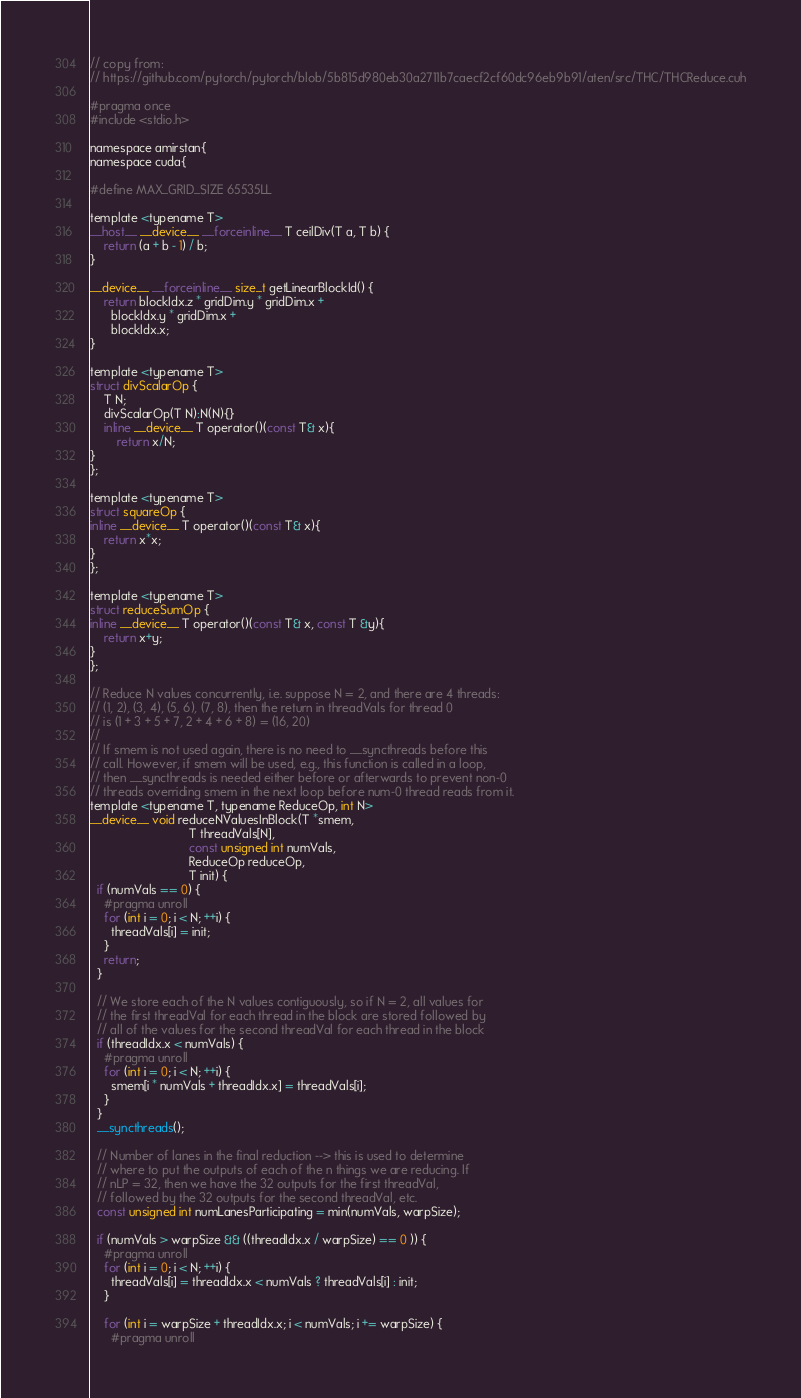Convert code to text. <code><loc_0><loc_0><loc_500><loc_500><_Cuda_>// copy from:
// https://github.com/pytorch/pytorch/blob/5b815d980eb30a2711b7caecf2cf60dc96eb9b91/aten/src/THC/THCReduce.cuh

#pragma once
#include <stdio.h>

namespace amirstan{
namespace cuda{

#define MAX_GRID_SIZE 65535LL

template <typename T>
__host__ __device__ __forceinline__ T ceilDiv(T a, T b) {
    return (a + b - 1) / b;
}

__device__ __forceinline__ size_t getLinearBlockId() {
    return blockIdx.z * gridDim.y * gridDim.x +
      blockIdx.y * gridDim.x +
      blockIdx.x;
}

template <typename T>
struct divScalarOp {
    T N;
    divScalarOp(T N):N(N){}
    inline __device__ T operator()(const T& x){
        return x/N;
}
};

template <typename T>
struct squareOp {
inline __device__ T operator()(const T& x){
    return x*x;
}
};

template <typename T>
struct reduceSumOp {
inline __device__ T operator()(const T& x, const T &y){
    return x+y;
}
};

// Reduce N values concurrently, i.e. suppose N = 2, and there are 4 threads:
// (1, 2), (3, 4), (5, 6), (7, 8), then the return in threadVals for thread 0
// is (1 + 3 + 5 + 7, 2 + 4 + 6 + 8) = (16, 20)
//
// If smem is not used again, there is no need to __syncthreads before this
// call. However, if smem will be used, e.g., this function is called in a loop,
// then __syncthreads is needed either before or afterwards to prevent non-0
// threads overriding smem in the next loop before num-0 thread reads from it.
template <typename T, typename ReduceOp, int N>
__device__ void reduceNValuesInBlock(T *smem,
                             T threadVals[N],
                             const unsigned int numVals,
                             ReduceOp reduceOp,
                             T init) {
  if (numVals == 0) {
    #pragma unroll
    for (int i = 0; i < N; ++i) {
      threadVals[i] = init;
    }
    return;
  }

  // We store each of the N values contiguously, so if N = 2, all values for
  // the first threadVal for each thread in the block are stored followed by
  // all of the values for the second threadVal for each thread in the block
  if (threadIdx.x < numVals) {
    #pragma unroll
    for (int i = 0; i < N; ++i) {
      smem[i * numVals + threadIdx.x] = threadVals[i];
    }
  }
  __syncthreads();

  // Number of lanes in the final reduction --> this is used to determine
  // where to put the outputs of each of the n things we are reducing. If
  // nLP = 32, then we have the 32 outputs for the first threadVal,
  // followed by the 32 outputs for the second threadVal, etc.
  const unsigned int numLanesParticipating = min(numVals, warpSize);

  if (numVals > warpSize && ((threadIdx.x / warpSize) == 0 )) {
    #pragma unroll
    for (int i = 0; i < N; ++i) {
      threadVals[i] = threadIdx.x < numVals ? threadVals[i] : init;
    }

    for (int i = warpSize + threadIdx.x; i < numVals; i += warpSize) {
      #pragma unroll</code> 